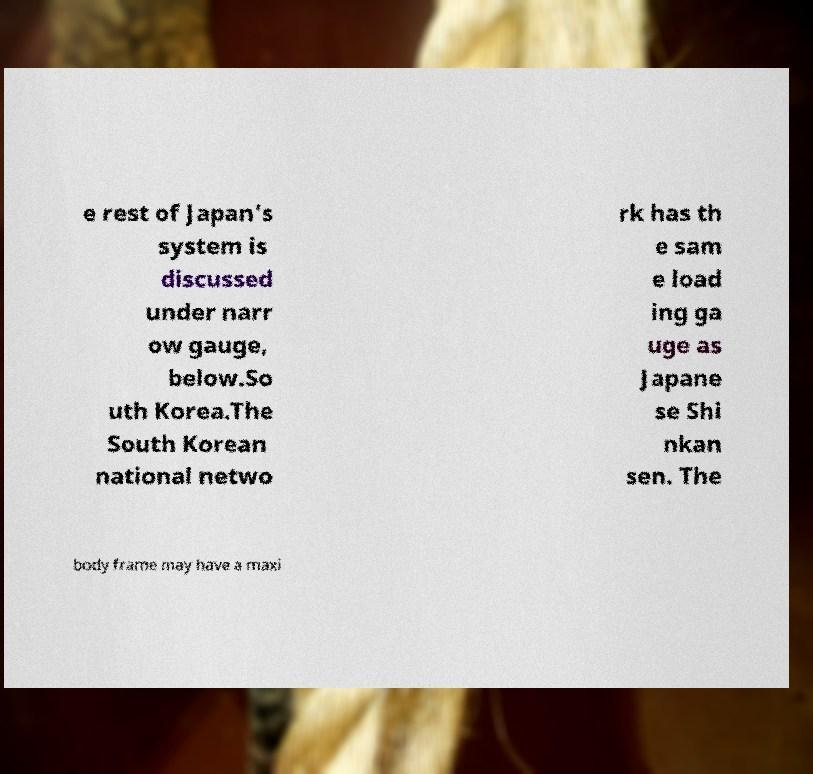Please identify and transcribe the text found in this image. e rest of Japan's system is discussed under narr ow gauge, below.So uth Korea.The South Korean national netwo rk has th e sam e load ing ga uge as Japane se Shi nkan sen. The body frame may have a maxi 